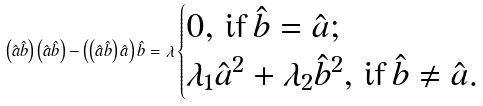Convert formula to latex. <formula><loc_0><loc_0><loc_500><loc_500>\left ( \hat { a } \hat { b } \right ) \left ( \hat { a } \hat { b } \right ) - \left ( \left ( \hat { a } \hat { b } \right ) \hat { a } \right ) \hat { b } = \lambda \begin{cases} 0 , \, \text {if} \, \hat { b } = \hat { a } ; \\ \lambda _ { 1 } \hat { a } ^ { 2 } + \lambda _ { 2 } \hat { b } ^ { 2 } , \, \text {if} \, \hat { b } \neq \hat { a } . \end{cases}</formula> 